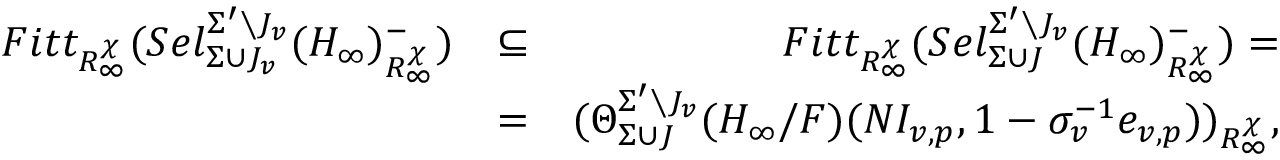Convert formula to latex. <formula><loc_0><loc_0><loc_500><loc_500>\begin{array} { r l r } { F i t t _ { R _ { \infty } ^ { \chi } } ( S e l _ { \Sigma \cup J _ { v } } ^ { \Sigma ^ { \prime } \ J _ { v } } ( H _ { \infty } ) _ { R _ { \infty } ^ { \chi } } ^ { - } ) } & { \subseteq } & { F i t t _ { R _ { \infty } ^ { \chi } } ( S e l _ { \Sigma \cup J } ^ { \Sigma ^ { \prime } \ J _ { v } } ( H _ { \infty } ) _ { R _ { \infty } ^ { \chi } } ^ { - } ) = } \\ & { = } & { ( \Theta _ { \Sigma \cup J } ^ { \Sigma ^ { \prime } \ J _ { v } } ( H _ { \infty } / F ) ( N I _ { v , p } , 1 - \sigma _ { v } ^ { - 1 } e _ { v , p } ) ) _ { R _ { \infty } ^ { \chi } } , } \end{array}</formula> 